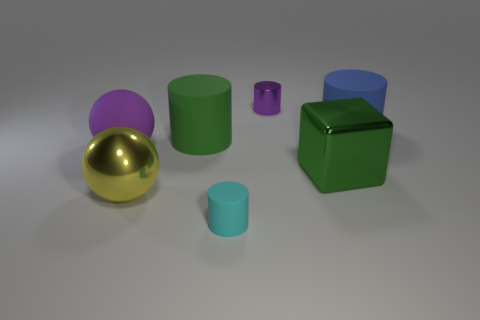Add 2 big matte balls. How many objects exist? 9 Subtract all tiny purple shiny cylinders. How many cylinders are left? 3 Subtract all purple cylinders. How many cylinders are left? 3 Subtract all purple matte spheres. Subtract all purple shiny objects. How many objects are left? 5 Add 5 large blue rubber things. How many large blue rubber things are left? 6 Add 2 large things. How many large things exist? 7 Subtract 1 yellow spheres. How many objects are left? 6 Subtract all cylinders. How many objects are left? 3 Subtract 1 balls. How many balls are left? 1 Subtract all gray cylinders. Subtract all cyan balls. How many cylinders are left? 4 